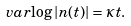Convert formula to latex. <formula><loc_0><loc_0><loc_500><loc_500>\ v a r { \log | n ( t ) | } = \kappa t .</formula> 